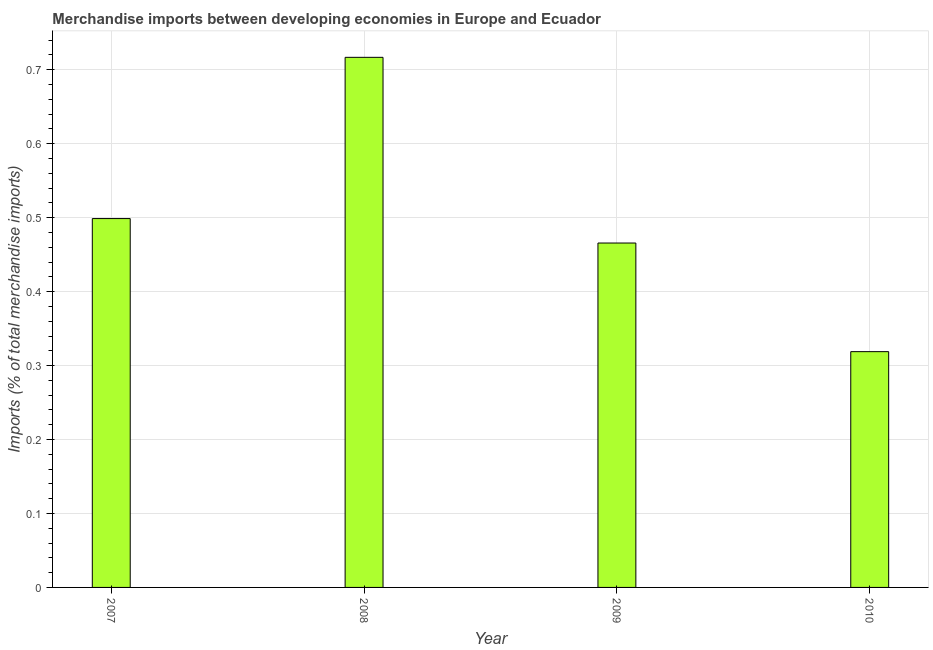Does the graph contain any zero values?
Your answer should be compact. No. What is the title of the graph?
Give a very brief answer. Merchandise imports between developing economies in Europe and Ecuador. What is the label or title of the X-axis?
Your answer should be compact. Year. What is the label or title of the Y-axis?
Give a very brief answer. Imports (% of total merchandise imports). What is the merchandise imports in 2009?
Provide a succinct answer. 0.47. Across all years, what is the maximum merchandise imports?
Keep it short and to the point. 0.72. Across all years, what is the minimum merchandise imports?
Make the answer very short. 0.32. What is the sum of the merchandise imports?
Offer a terse response. 2. What is the difference between the merchandise imports in 2007 and 2008?
Your answer should be compact. -0.22. What is the median merchandise imports?
Ensure brevity in your answer.  0.48. In how many years, is the merchandise imports greater than 0.66 %?
Offer a very short reply. 1. Do a majority of the years between 2008 and 2010 (inclusive) have merchandise imports greater than 0.46 %?
Ensure brevity in your answer.  Yes. What is the ratio of the merchandise imports in 2008 to that in 2009?
Make the answer very short. 1.54. What is the difference between the highest and the second highest merchandise imports?
Your answer should be compact. 0.22. In how many years, is the merchandise imports greater than the average merchandise imports taken over all years?
Keep it short and to the point. 1. How many bars are there?
Offer a very short reply. 4. How many years are there in the graph?
Make the answer very short. 4. What is the Imports (% of total merchandise imports) in 2007?
Provide a short and direct response. 0.5. What is the Imports (% of total merchandise imports) of 2008?
Your answer should be compact. 0.72. What is the Imports (% of total merchandise imports) of 2009?
Offer a terse response. 0.47. What is the Imports (% of total merchandise imports) in 2010?
Your answer should be compact. 0.32. What is the difference between the Imports (% of total merchandise imports) in 2007 and 2008?
Provide a succinct answer. -0.22. What is the difference between the Imports (% of total merchandise imports) in 2007 and 2009?
Offer a very short reply. 0.03. What is the difference between the Imports (% of total merchandise imports) in 2007 and 2010?
Make the answer very short. 0.18. What is the difference between the Imports (% of total merchandise imports) in 2008 and 2009?
Offer a very short reply. 0.25. What is the difference between the Imports (% of total merchandise imports) in 2008 and 2010?
Give a very brief answer. 0.4. What is the difference between the Imports (% of total merchandise imports) in 2009 and 2010?
Provide a succinct answer. 0.15. What is the ratio of the Imports (% of total merchandise imports) in 2007 to that in 2008?
Provide a succinct answer. 0.7. What is the ratio of the Imports (% of total merchandise imports) in 2007 to that in 2009?
Ensure brevity in your answer.  1.07. What is the ratio of the Imports (% of total merchandise imports) in 2007 to that in 2010?
Ensure brevity in your answer.  1.56. What is the ratio of the Imports (% of total merchandise imports) in 2008 to that in 2009?
Make the answer very short. 1.54. What is the ratio of the Imports (% of total merchandise imports) in 2008 to that in 2010?
Offer a very short reply. 2.25. What is the ratio of the Imports (% of total merchandise imports) in 2009 to that in 2010?
Keep it short and to the point. 1.46. 